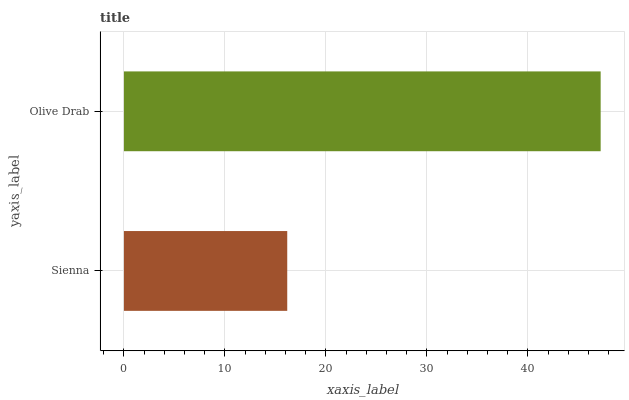Is Sienna the minimum?
Answer yes or no. Yes. Is Olive Drab the maximum?
Answer yes or no. Yes. Is Olive Drab the minimum?
Answer yes or no. No. Is Olive Drab greater than Sienna?
Answer yes or no. Yes. Is Sienna less than Olive Drab?
Answer yes or no. Yes. Is Sienna greater than Olive Drab?
Answer yes or no. No. Is Olive Drab less than Sienna?
Answer yes or no. No. Is Olive Drab the high median?
Answer yes or no. Yes. Is Sienna the low median?
Answer yes or no. Yes. Is Sienna the high median?
Answer yes or no. No. Is Olive Drab the low median?
Answer yes or no. No. 